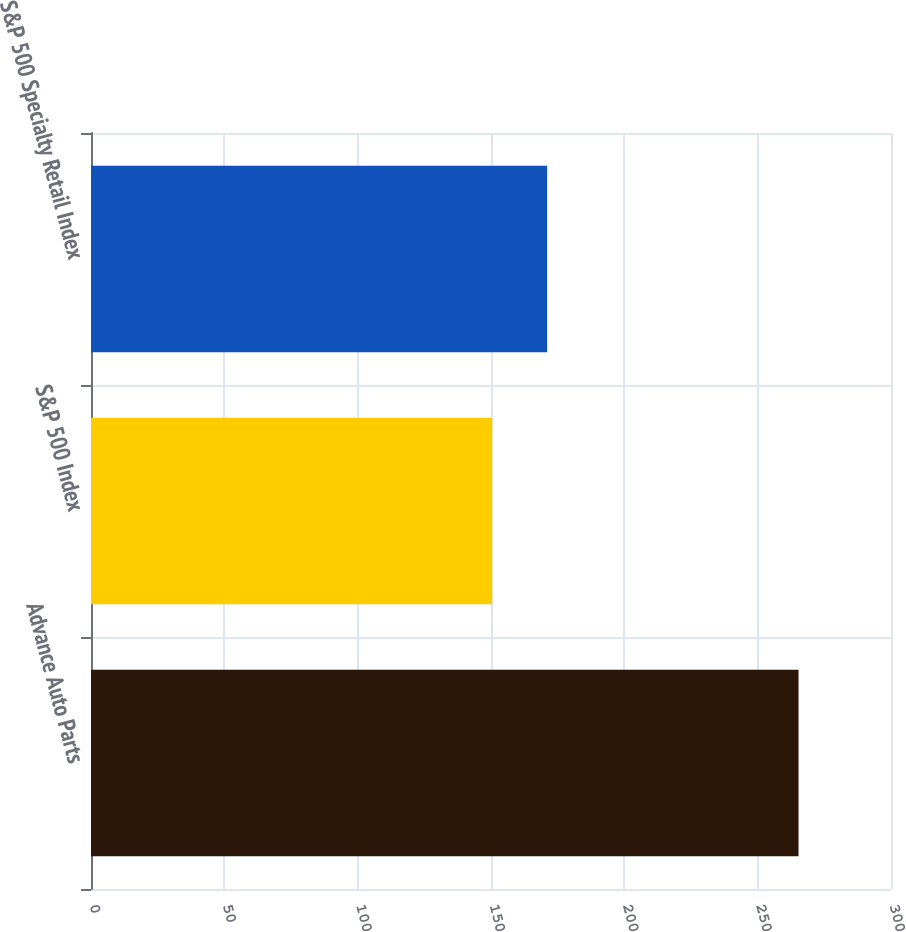Convert chart. <chart><loc_0><loc_0><loc_500><loc_500><bar_chart><fcel>Advance Auto Parts<fcel>S&P 500 Index<fcel>S&P 500 Specialty Retail Index<nl><fcel>265.32<fcel>150.45<fcel>171.04<nl></chart> 